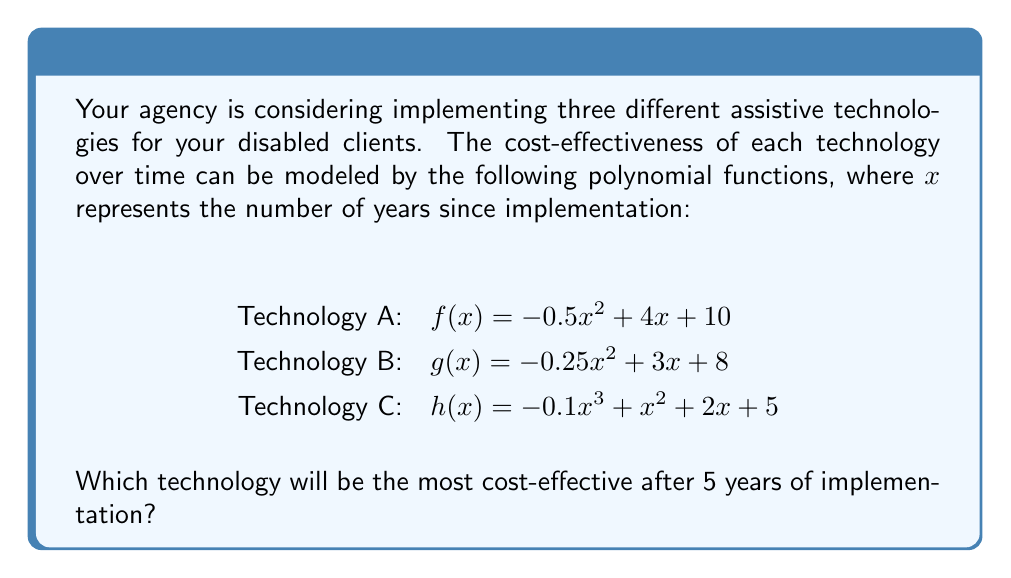Teach me how to tackle this problem. To determine the most cost-effective technology after 5 years, we need to evaluate each function at $x = 5$ and compare the results.

1. For Technology A:
   $f(5) = -0.5(5)^2 + 4(5) + 10$
   $= -0.5(25) + 20 + 10$
   $= -12.5 + 20 + 10$
   $= 17.5$

2. For Technology B:
   $g(5) = -0.25(5)^2 + 3(5) + 8$
   $= -0.25(25) + 15 + 8$
   $= -6.25 + 15 + 8$
   $= 16.75$

3. For Technology C:
   $h(5) = -0.1(5)^3 + (5)^2 + 2(5) + 5$
   $= -0.1(125) + 25 + 10 + 5$
   $= -12.5 + 25 + 10 + 5$
   $= 27.5$

Comparing the results:
Technology A: 17.5
Technology B: 16.75
Technology C: 27.5

Technology C has the highest value after 5 years, making it the most cost-effective option.
Answer: Technology C 